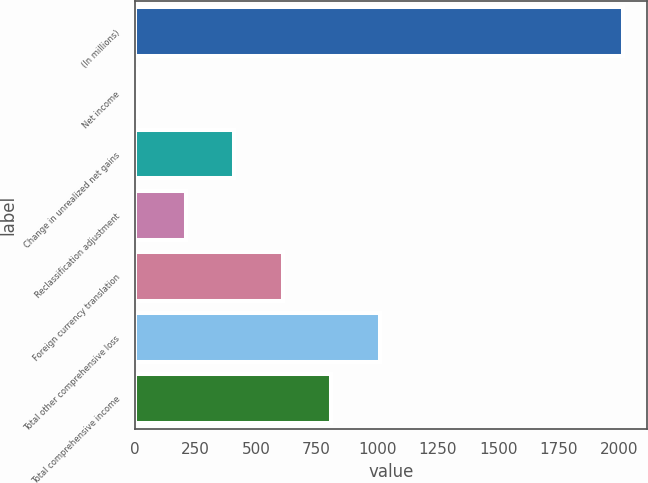Convert chart to OTSL. <chart><loc_0><loc_0><loc_500><loc_500><bar_chart><fcel>(In millions)<fcel>Net income<fcel>Change in unrealized net gains<fcel>Reclassification adjustment<fcel>Foreign currency translation<fcel>Total other comprehensive loss<fcel>Total comprehensive income<nl><fcel>2014<fcel>8<fcel>409.2<fcel>208.6<fcel>609.8<fcel>1011<fcel>810.4<nl></chart> 